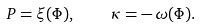<formula> <loc_0><loc_0><loc_500><loc_500>P = \xi ( \Phi ) , \quad \kappa = - \, \omega ( \Phi ) .</formula> 